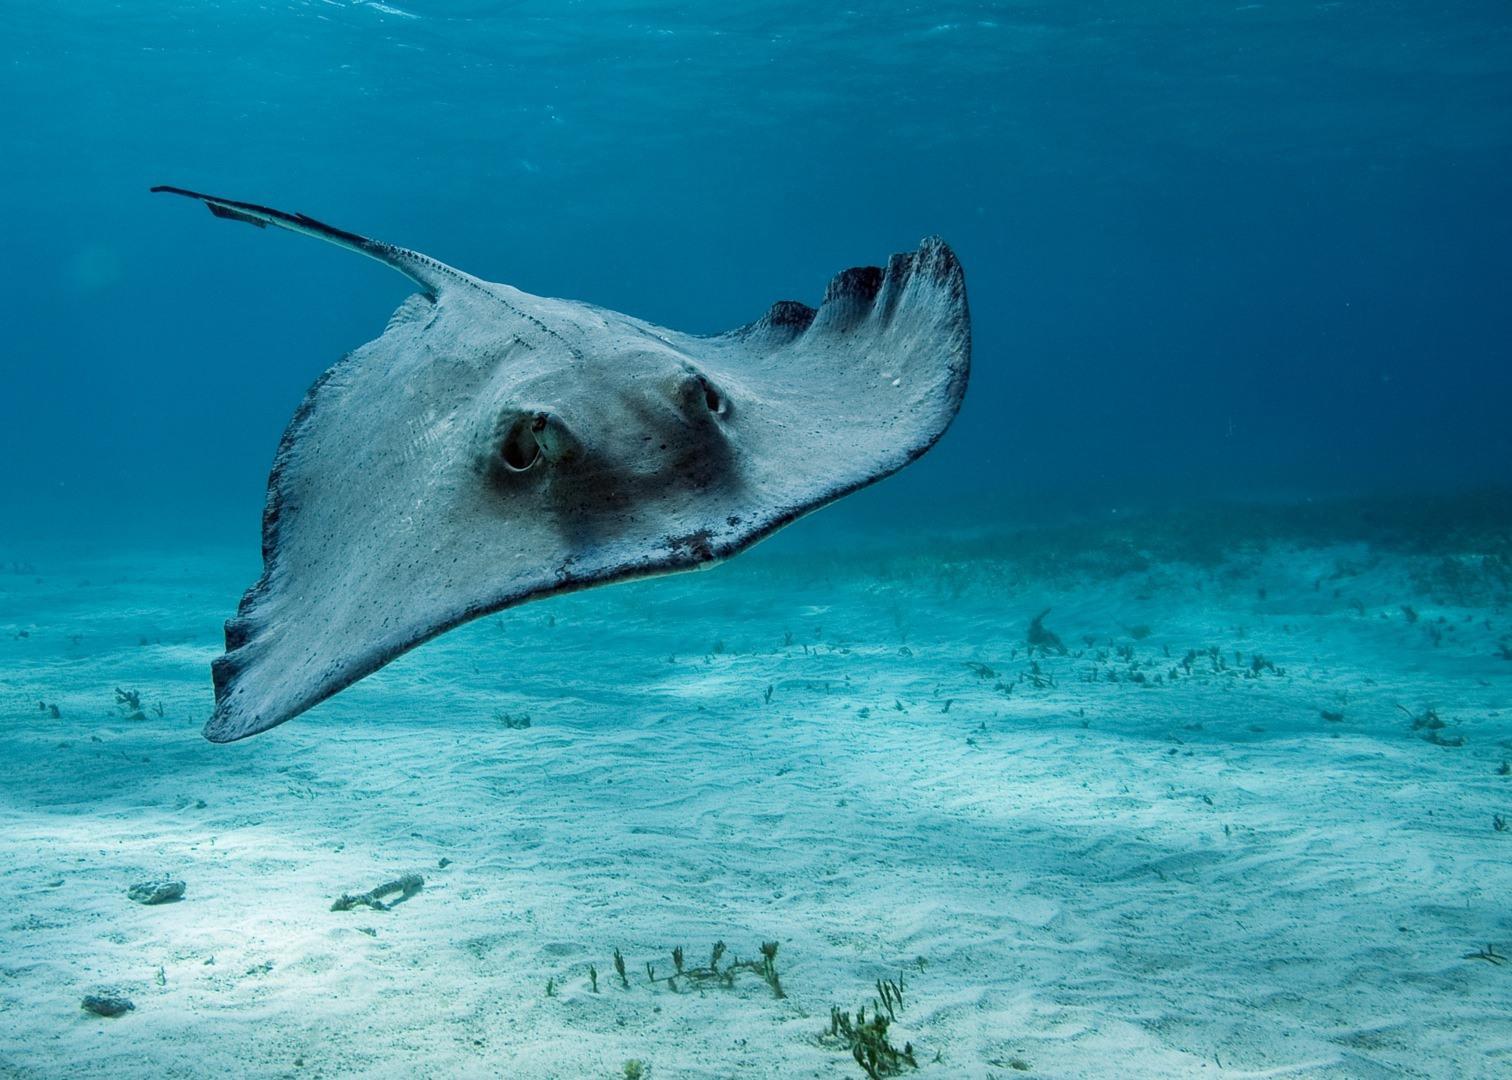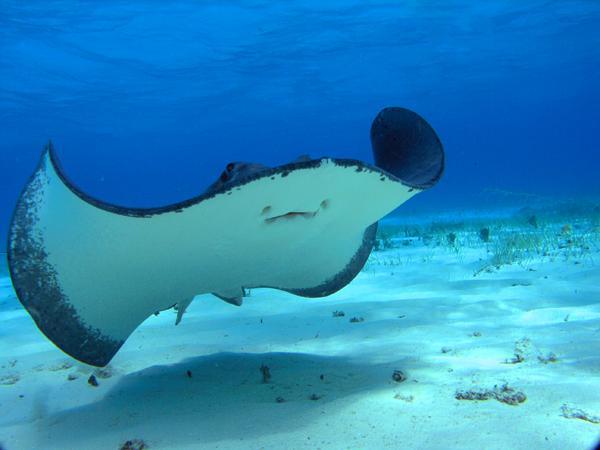The first image is the image on the left, the second image is the image on the right. Examine the images to the left and right. Is the description "One image shows the underbelly of a stingray in the foreground, and the other shows the top view of a dark blue stingray without distinctive spots." accurate? Answer yes or no. Yes. The first image is the image on the left, the second image is the image on the right. For the images displayed, is the sentence "The stingray on the right image is touching sand." factually correct? Answer yes or no. No. 